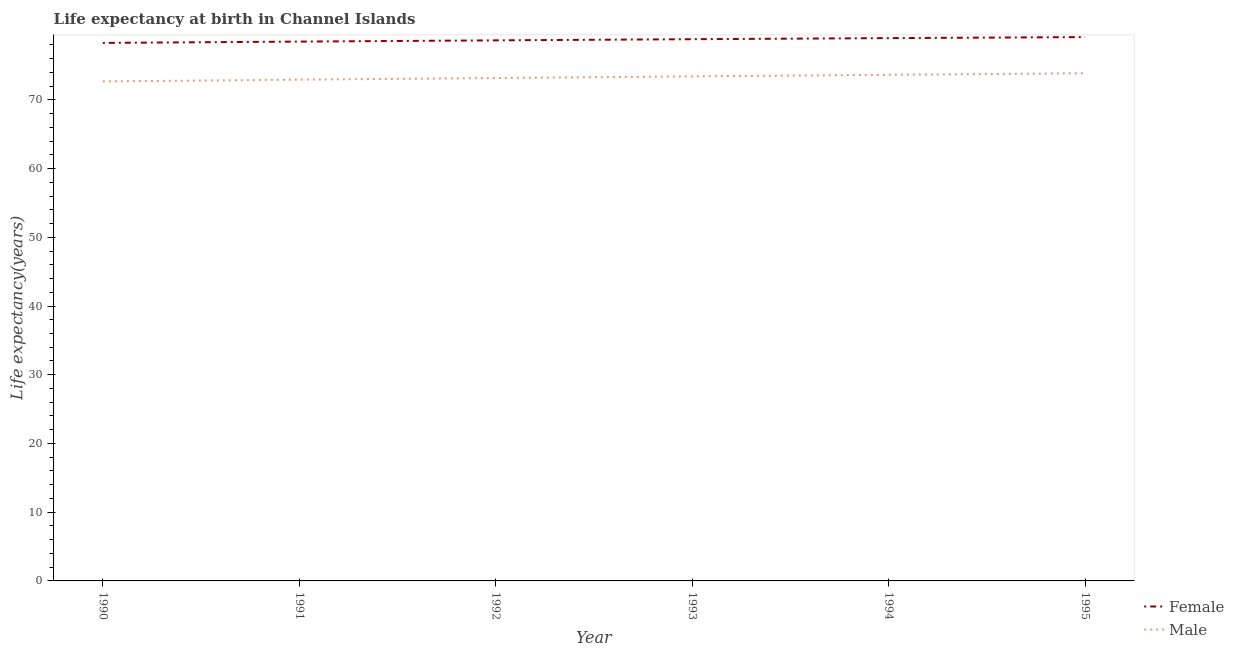How many different coloured lines are there?
Provide a succinct answer. 2. Does the line corresponding to life expectancy(female) intersect with the line corresponding to life expectancy(male)?
Give a very brief answer. No. What is the life expectancy(female) in 1994?
Provide a succinct answer. 78.98. Across all years, what is the maximum life expectancy(female)?
Give a very brief answer. 79.13. Across all years, what is the minimum life expectancy(male)?
Give a very brief answer. 72.69. In which year was the life expectancy(male) minimum?
Your answer should be very brief. 1990. What is the total life expectancy(male) in the graph?
Make the answer very short. 439.73. What is the difference between the life expectancy(female) in 1990 and that in 1991?
Offer a very short reply. -0.19. What is the difference between the life expectancy(male) in 1993 and the life expectancy(female) in 1995?
Provide a short and direct response. -5.72. What is the average life expectancy(female) per year?
Provide a succinct answer. 78.73. In the year 1993, what is the difference between the life expectancy(female) and life expectancy(male)?
Provide a short and direct response. 5.41. In how many years, is the life expectancy(male) greater than 20 years?
Offer a very short reply. 6. What is the ratio of the life expectancy(male) in 1991 to that in 1994?
Your answer should be compact. 0.99. Is the life expectancy(male) in 1994 less than that in 1995?
Give a very brief answer. Yes. What is the difference between the highest and the second highest life expectancy(female)?
Provide a succinct answer. 0.15. What is the difference between the highest and the lowest life expectancy(female)?
Provide a short and direct response. 0.85. Does the life expectancy(female) monotonically increase over the years?
Your response must be concise. Yes. Is the life expectancy(female) strictly greater than the life expectancy(male) over the years?
Your response must be concise. Yes. Is the life expectancy(female) strictly less than the life expectancy(male) over the years?
Ensure brevity in your answer.  No. How many years are there in the graph?
Your answer should be very brief. 6. Are the values on the major ticks of Y-axis written in scientific E-notation?
Make the answer very short. No. Does the graph contain any zero values?
Provide a succinct answer. No. Does the graph contain grids?
Keep it short and to the point. No. Where does the legend appear in the graph?
Give a very brief answer. Bottom right. How many legend labels are there?
Ensure brevity in your answer.  2. How are the legend labels stacked?
Your answer should be compact. Vertical. What is the title of the graph?
Give a very brief answer. Life expectancy at birth in Channel Islands. Does "Female" appear as one of the legend labels in the graph?
Ensure brevity in your answer.  Yes. What is the label or title of the Y-axis?
Make the answer very short. Life expectancy(years). What is the Life expectancy(years) in Female in 1990?
Keep it short and to the point. 78.28. What is the Life expectancy(years) of Male in 1990?
Ensure brevity in your answer.  72.69. What is the Life expectancy(years) of Female in 1991?
Your answer should be very brief. 78.47. What is the Life expectancy(years) in Male in 1991?
Give a very brief answer. 72.93. What is the Life expectancy(years) of Female in 1992?
Ensure brevity in your answer.  78.66. What is the Life expectancy(years) of Male in 1992?
Provide a short and direct response. 73.18. What is the Life expectancy(years) of Female in 1993?
Make the answer very short. 78.83. What is the Life expectancy(years) in Male in 1993?
Provide a short and direct response. 73.41. What is the Life expectancy(years) in Female in 1994?
Ensure brevity in your answer.  78.98. What is the Life expectancy(years) of Male in 1994?
Offer a terse response. 73.64. What is the Life expectancy(years) of Female in 1995?
Your answer should be very brief. 79.13. What is the Life expectancy(years) in Male in 1995?
Ensure brevity in your answer.  73.87. Across all years, what is the maximum Life expectancy(years) in Female?
Provide a succinct answer. 79.13. Across all years, what is the maximum Life expectancy(years) in Male?
Offer a terse response. 73.87. Across all years, what is the minimum Life expectancy(years) of Female?
Offer a very short reply. 78.28. Across all years, what is the minimum Life expectancy(years) of Male?
Your answer should be very brief. 72.69. What is the total Life expectancy(years) in Female in the graph?
Provide a succinct answer. 472.35. What is the total Life expectancy(years) in Male in the graph?
Provide a short and direct response. 439.73. What is the difference between the Life expectancy(years) in Female in 1990 and that in 1991?
Make the answer very short. -0.19. What is the difference between the Life expectancy(years) in Male in 1990 and that in 1991?
Your answer should be very brief. -0.25. What is the difference between the Life expectancy(years) in Female in 1990 and that in 1992?
Keep it short and to the point. -0.37. What is the difference between the Life expectancy(years) of Male in 1990 and that in 1992?
Offer a terse response. -0.49. What is the difference between the Life expectancy(years) of Female in 1990 and that in 1993?
Your response must be concise. -0.54. What is the difference between the Life expectancy(years) in Male in 1990 and that in 1993?
Your answer should be very brief. -0.72. What is the difference between the Life expectancy(years) in Female in 1990 and that in 1994?
Give a very brief answer. -0.7. What is the difference between the Life expectancy(years) of Male in 1990 and that in 1994?
Your answer should be very brief. -0.95. What is the difference between the Life expectancy(years) of Female in 1990 and that in 1995?
Offer a terse response. -0.85. What is the difference between the Life expectancy(years) of Male in 1990 and that in 1995?
Offer a terse response. -1.18. What is the difference between the Life expectancy(years) of Female in 1991 and that in 1992?
Your answer should be very brief. -0.18. What is the difference between the Life expectancy(years) of Male in 1991 and that in 1992?
Provide a succinct answer. -0.24. What is the difference between the Life expectancy(years) of Female in 1991 and that in 1993?
Give a very brief answer. -0.35. What is the difference between the Life expectancy(years) of Male in 1991 and that in 1993?
Ensure brevity in your answer.  -0.48. What is the difference between the Life expectancy(years) in Female in 1991 and that in 1994?
Provide a short and direct response. -0.51. What is the difference between the Life expectancy(years) in Male in 1991 and that in 1994?
Your response must be concise. -0.71. What is the difference between the Life expectancy(years) in Female in 1991 and that in 1995?
Provide a succinct answer. -0.66. What is the difference between the Life expectancy(years) in Male in 1991 and that in 1995?
Provide a succinct answer. -0.94. What is the difference between the Life expectancy(years) in Female in 1992 and that in 1993?
Your answer should be compact. -0.17. What is the difference between the Life expectancy(years) of Male in 1992 and that in 1993?
Offer a terse response. -0.24. What is the difference between the Life expectancy(years) in Female in 1992 and that in 1994?
Your response must be concise. -0.33. What is the difference between the Life expectancy(years) in Male in 1992 and that in 1994?
Your response must be concise. -0.47. What is the difference between the Life expectancy(years) of Female in 1992 and that in 1995?
Your answer should be compact. -0.47. What is the difference between the Life expectancy(years) of Male in 1992 and that in 1995?
Ensure brevity in your answer.  -0.69. What is the difference between the Life expectancy(years) of Female in 1993 and that in 1994?
Offer a very short reply. -0.16. What is the difference between the Life expectancy(years) of Male in 1993 and that in 1994?
Offer a very short reply. -0.23. What is the difference between the Life expectancy(years) in Female in 1993 and that in 1995?
Your response must be concise. -0.31. What is the difference between the Life expectancy(years) in Male in 1993 and that in 1995?
Make the answer very short. -0.46. What is the difference between the Life expectancy(years) in Female in 1994 and that in 1995?
Keep it short and to the point. -0.15. What is the difference between the Life expectancy(years) of Male in 1994 and that in 1995?
Ensure brevity in your answer.  -0.23. What is the difference between the Life expectancy(years) of Female in 1990 and the Life expectancy(years) of Male in 1991?
Give a very brief answer. 5.35. What is the difference between the Life expectancy(years) in Female in 1990 and the Life expectancy(years) in Male in 1992?
Ensure brevity in your answer.  5.11. What is the difference between the Life expectancy(years) of Female in 1990 and the Life expectancy(years) of Male in 1993?
Keep it short and to the point. 4.87. What is the difference between the Life expectancy(years) of Female in 1990 and the Life expectancy(years) of Male in 1994?
Your response must be concise. 4.64. What is the difference between the Life expectancy(years) in Female in 1990 and the Life expectancy(years) in Male in 1995?
Ensure brevity in your answer.  4.41. What is the difference between the Life expectancy(years) in Female in 1991 and the Life expectancy(years) in Male in 1992?
Your response must be concise. 5.3. What is the difference between the Life expectancy(years) in Female in 1991 and the Life expectancy(years) in Male in 1993?
Provide a short and direct response. 5.06. What is the difference between the Life expectancy(years) in Female in 1991 and the Life expectancy(years) in Male in 1994?
Offer a terse response. 4.83. What is the difference between the Life expectancy(years) in Female in 1991 and the Life expectancy(years) in Male in 1995?
Your answer should be compact. 4.6. What is the difference between the Life expectancy(years) of Female in 1992 and the Life expectancy(years) of Male in 1993?
Your answer should be very brief. 5.24. What is the difference between the Life expectancy(years) in Female in 1992 and the Life expectancy(years) in Male in 1994?
Give a very brief answer. 5.01. What is the difference between the Life expectancy(years) of Female in 1992 and the Life expectancy(years) of Male in 1995?
Your answer should be compact. 4.79. What is the difference between the Life expectancy(years) of Female in 1993 and the Life expectancy(years) of Male in 1994?
Your answer should be very brief. 5.18. What is the difference between the Life expectancy(years) in Female in 1993 and the Life expectancy(years) in Male in 1995?
Your answer should be compact. 4.95. What is the difference between the Life expectancy(years) of Female in 1994 and the Life expectancy(years) of Male in 1995?
Keep it short and to the point. 5.11. What is the average Life expectancy(years) of Female per year?
Make the answer very short. 78.73. What is the average Life expectancy(years) of Male per year?
Your response must be concise. 73.29. In the year 1990, what is the difference between the Life expectancy(years) of Female and Life expectancy(years) of Male?
Your answer should be very brief. 5.6. In the year 1991, what is the difference between the Life expectancy(years) of Female and Life expectancy(years) of Male?
Provide a short and direct response. 5.54. In the year 1992, what is the difference between the Life expectancy(years) of Female and Life expectancy(years) of Male?
Offer a terse response. 5.48. In the year 1993, what is the difference between the Life expectancy(years) of Female and Life expectancy(years) of Male?
Keep it short and to the point. 5.41. In the year 1994, what is the difference between the Life expectancy(years) of Female and Life expectancy(years) of Male?
Ensure brevity in your answer.  5.34. In the year 1995, what is the difference between the Life expectancy(years) in Female and Life expectancy(years) in Male?
Offer a terse response. 5.26. What is the ratio of the Life expectancy(years) of Male in 1990 to that in 1992?
Keep it short and to the point. 0.99. What is the ratio of the Life expectancy(years) in Male in 1990 to that in 1993?
Provide a succinct answer. 0.99. What is the ratio of the Life expectancy(years) in Male in 1990 to that in 1994?
Ensure brevity in your answer.  0.99. What is the ratio of the Life expectancy(years) of Female in 1990 to that in 1995?
Provide a short and direct response. 0.99. What is the ratio of the Life expectancy(years) of Male in 1990 to that in 1995?
Give a very brief answer. 0.98. What is the ratio of the Life expectancy(years) of Female in 1991 to that in 1992?
Give a very brief answer. 1. What is the ratio of the Life expectancy(years) of Male in 1991 to that in 1995?
Offer a terse response. 0.99. What is the ratio of the Life expectancy(years) of Male in 1992 to that in 1995?
Your response must be concise. 0.99. What is the ratio of the Life expectancy(years) of Male in 1993 to that in 1994?
Your answer should be compact. 1. What is the ratio of the Life expectancy(years) in Female in 1994 to that in 1995?
Offer a terse response. 1. What is the ratio of the Life expectancy(years) in Male in 1994 to that in 1995?
Make the answer very short. 1. What is the difference between the highest and the second highest Life expectancy(years) of Female?
Your answer should be compact. 0.15. What is the difference between the highest and the second highest Life expectancy(years) of Male?
Keep it short and to the point. 0.23. What is the difference between the highest and the lowest Life expectancy(years) of Female?
Ensure brevity in your answer.  0.85. What is the difference between the highest and the lowest Life expectancy(years) in Male?
Provide a succinct answer. 1.18. 